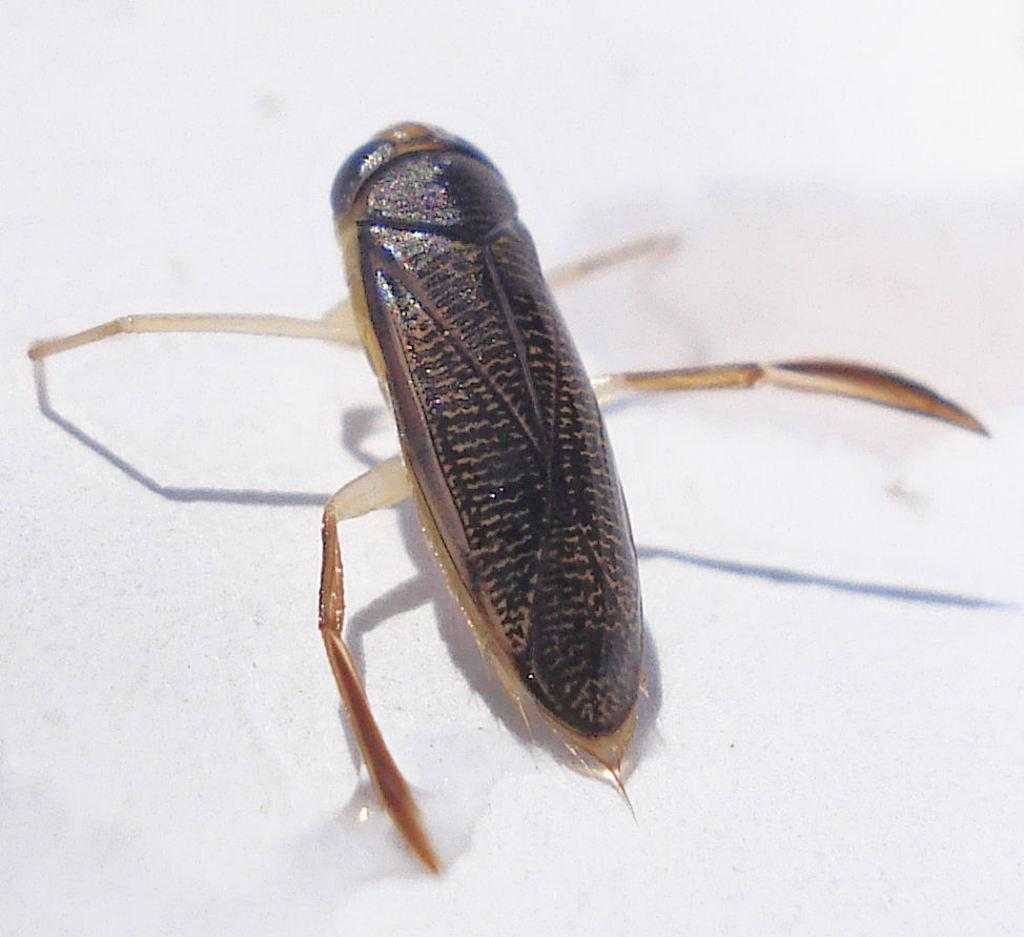What type of creature is present in the image? There is an insect in the image. What body parts does the insect have? The insect has legs. What color is the background of the image? The background of the image appears to be white in color. How does the insect compare to a key in the image? There is no key present in the image, so it cannot be compared to the insect. 